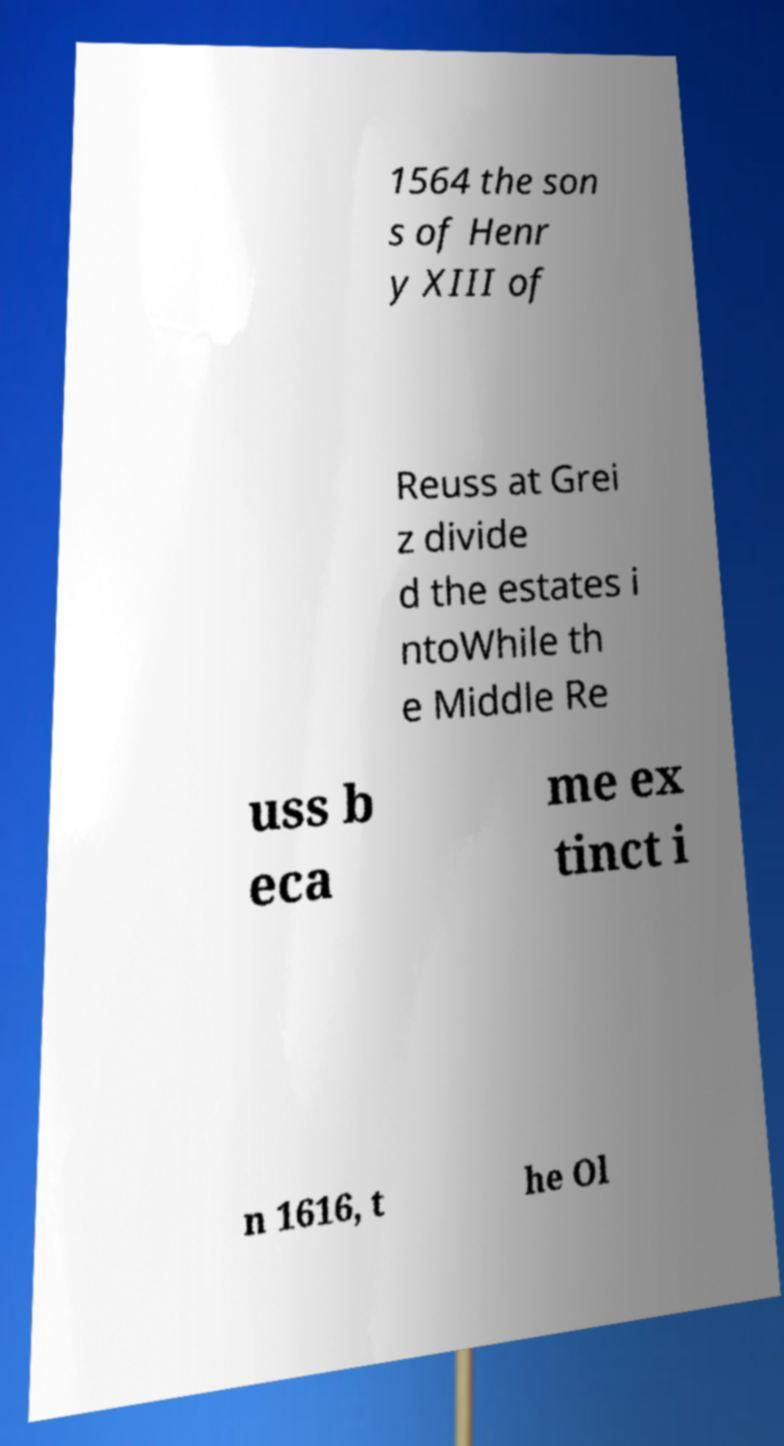Please read and relay the text visible in this image. What does it say? 1564 the son s of Henr y XIII of Reuss at Grei z divide d the estates i ntoWhile th e Middle Re uss b eca me ex tinct i n 1616, t he Ol 